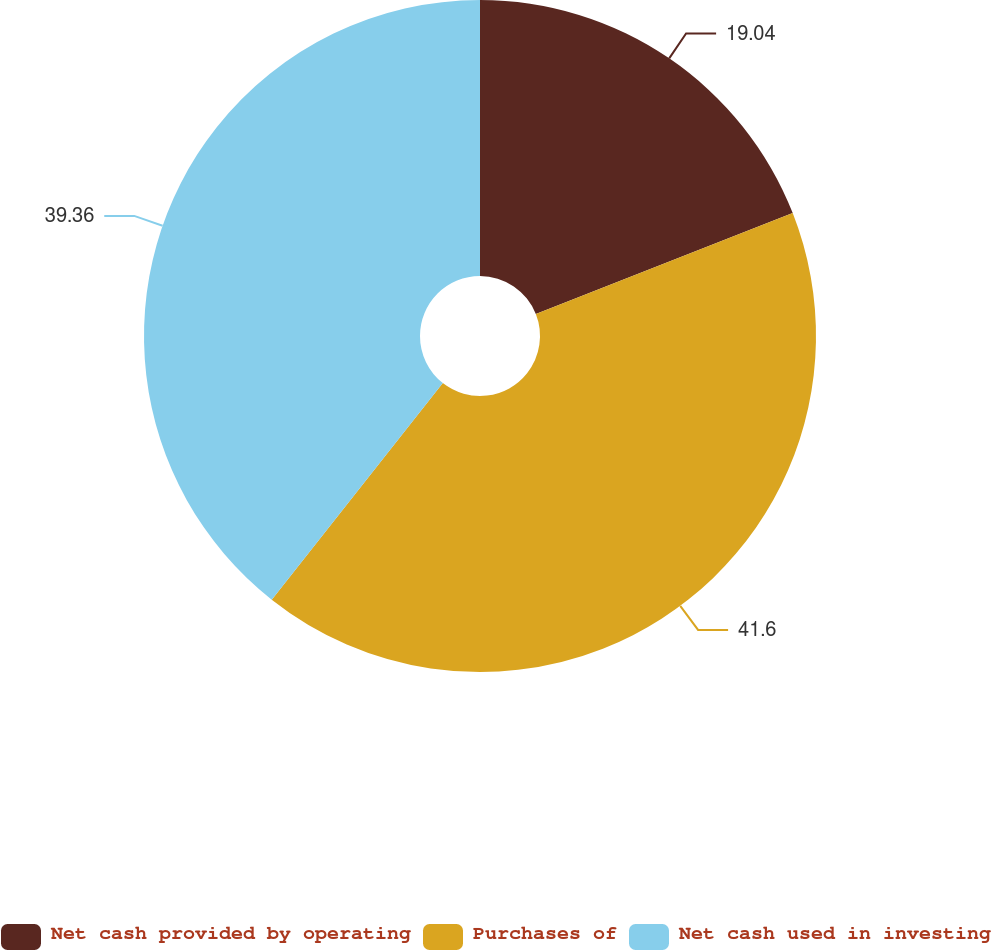<chart> <loc_0><loc_0><loc_500><loc_500><pie_chart><fcel>Net cash provided by operating<fcel>Purchases of<fcel>Net cash used in investing<nl><fcel>19.04%<fcel>41.6%<fcel>39.36%<nl></chart> 